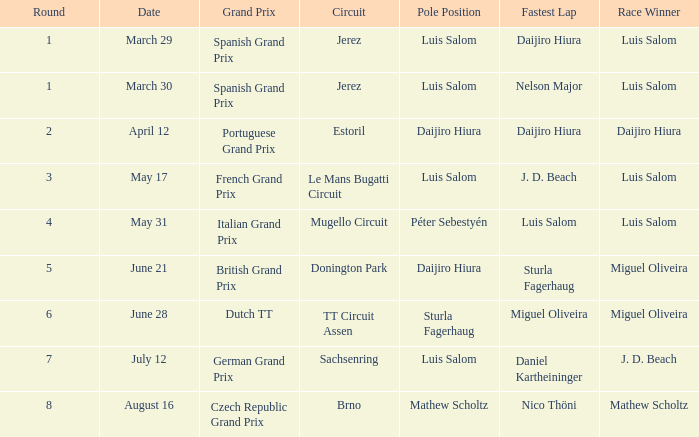Who had the fastest lap in the Dutch TT Grand Prix?  Miguel Oliveira. 